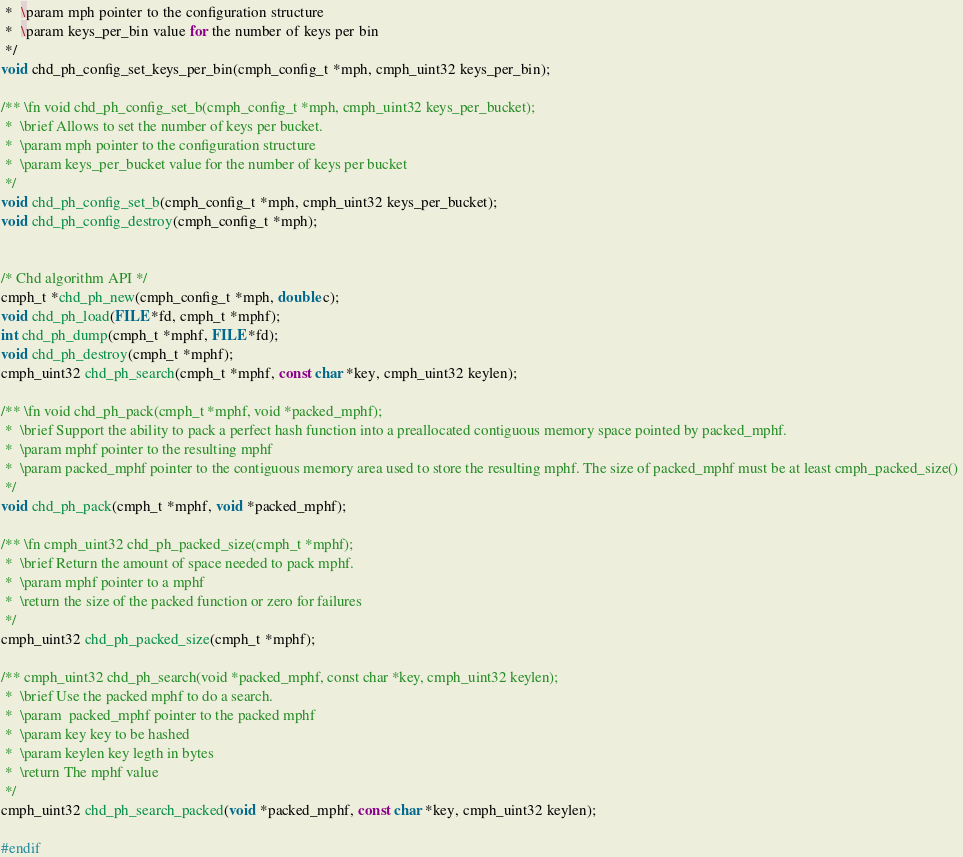Convert code to text. <code><loc_0><loc_0><loc_500><loc_500><_C_> *  \param mph pointer to the configuration structure
 *  \param keys_per_bin value for the number of keys per bin 
 */
void chd_ph_config_set_keys_per_bin(cmph_config_t *mph, cmph_uint32 keys_per_bin);

/** \fn void chd_ph_config_set_b(cmph_config_t *mph, cmph_uint32 keys_per_bucket);
 *  \brief Allows to set the number of keys per bucket.
 *  \param mph pointer to the configuration structure
 *  \param keys_per_bucket value for the number of keys per bucket 
 */
void chd_ph_config_set_b(cmph_config_t *mph, cmph_uint32 keys_per_bucket);
void chd_ph_config_destroy(cmph_config_t *mph);


/* Chd algorithm API */
cmph_t *chd_ph_new(cmph_config_t *mph, double c);
void chd_ph_load(FILE *fd, cmph_t *mphf);
int chd_ph_dump(cmph_t *mphf, FILE *fd);
void chd_ph_destroy(cmph_t *mphf);
cmph_uint32 chd_ph_search(cmph_t *mphf, const char *key, cmph_uint32 keylen);

/** \fn void chd_ph_pack(cmph_t *mphf, void *packed_mphf);
 *  \brief Support the ability to pack a perfect hash function into a preallocated contiguous memory space pointed by packed_mphf.
 *  \param mphf pointer to the resulting mphf
 *  \param packed_mphf pointer to the contiguous memory area used to store the resulting mphf. The size of packed_mphf must be at least cmph_packed_size() 
 */
void chd_ph_pack(cmph_t *mphf, void *packed_mphf);

/** \fn cmph_uint32 chd_ph_packed_size(cmph_t *mphf);
 *  \brief Return the amount of space needed to pack mphf.
 *  \param mphf pointer to a mphf
 *  \return the size of the packed function or zero for failures
 */ 
cmph_uint32 chd_ph_packed_size(cmph_t *mphf);

/** cmph_uint32 chd_ph_search(void *packed_mphf, const char *key, cmph_uint32 keylen);
 *  \brief Use the packed mphf to do a search. 
 *  \param  packed_mphf pointer to the packed mphf
 *  \param key key to be hashed
 *  \param keylen key legth in bytes
 *  \return The mphf value
 */
cmph_uint32 chd_ph_search_packed(void *packed_mphf, const char *key, cmph_uint32 keylen);

#endif
</code> 